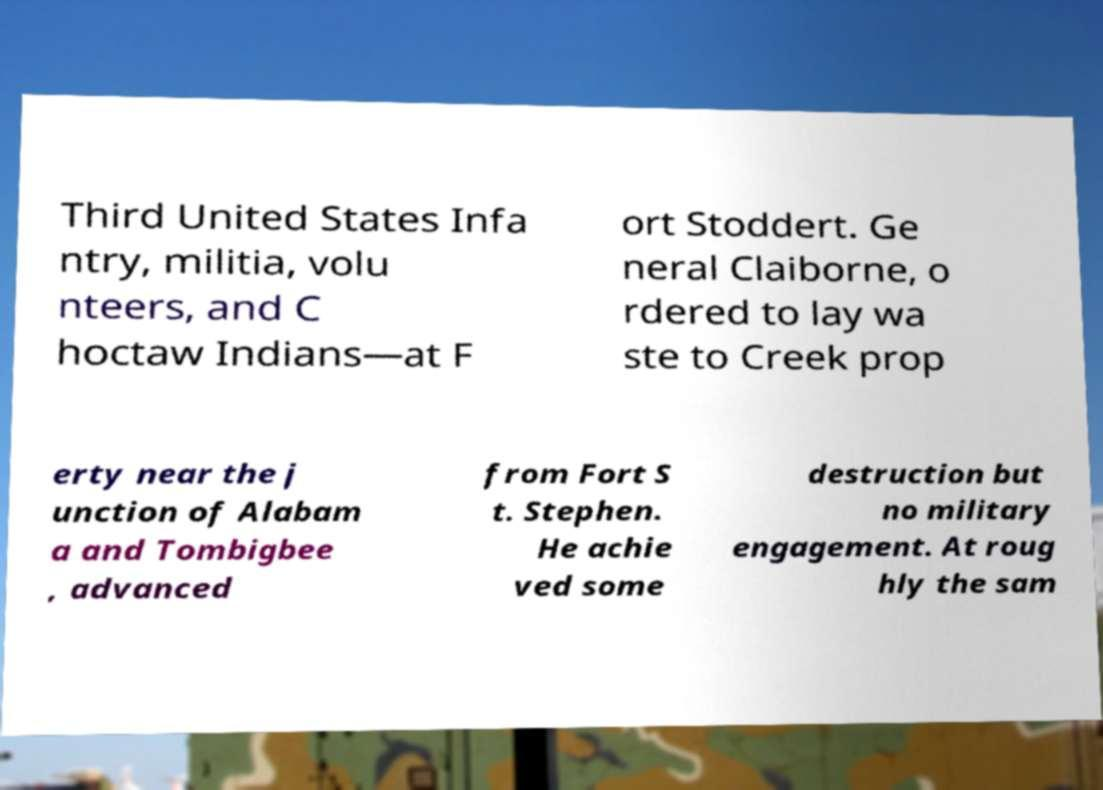Can you accurately transcribe the text from the provided image for me? Third United States Infa ntry, militia, volu nteers, and C hoctaw Indians—at F ort Stoddert. Ge neral Claiborne, o rdered to lay wa ste to Creek prop erty near the j unction of Alabam a and Tombigbee , advanced from Fort S t. Stephen. He achie ved some destruction but no military engagement. At roug hly the sam 